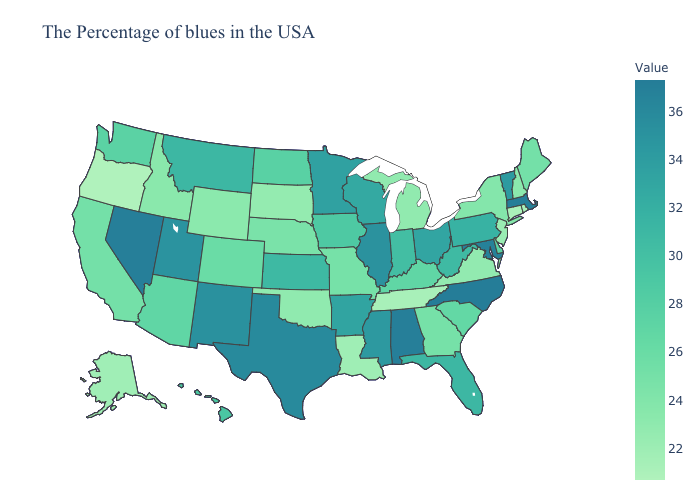Which states have the highest value in the USA?
Keep it brief. North Carolina. Among the states that border Arizona , which have the highest value?
Keep it brief. Nevada. Which states have the lowest value in the Northeast?
Concise answer only. Connecticut. Does California have the highest value in the USA?
Quick response, please. No. Which states have the lowest value in the South?
Be succinct. Tennessee. Which states have the lowest value in the USA?
Be succinct. Oregon. 